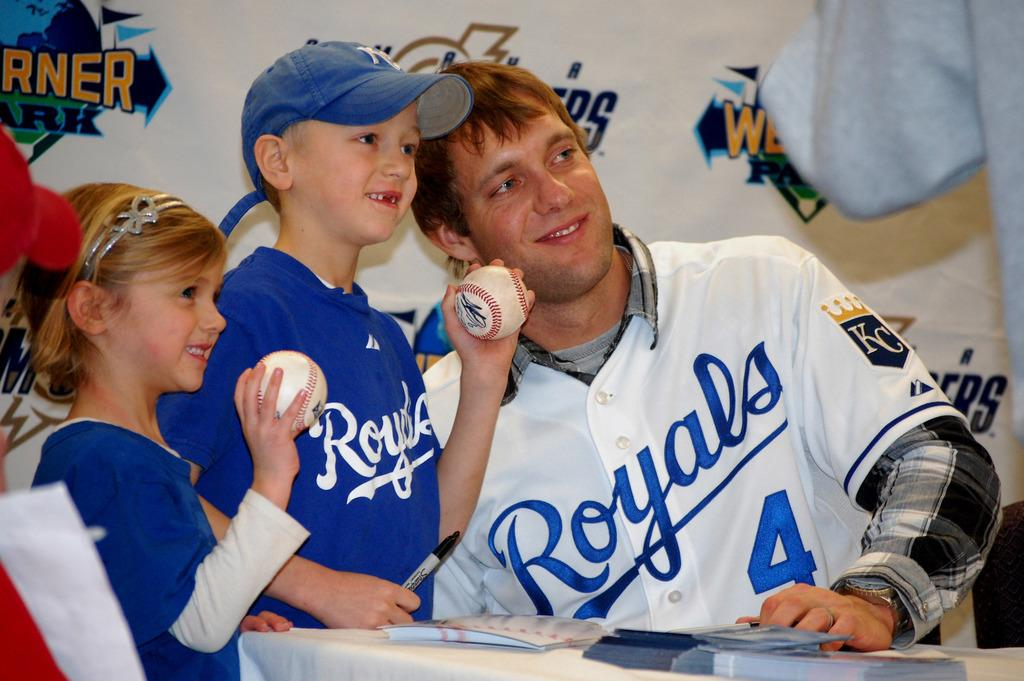<image>
Give a short and clear explanation of the subsequent image. Man wearing a Royals jersey posing with a little boy. 